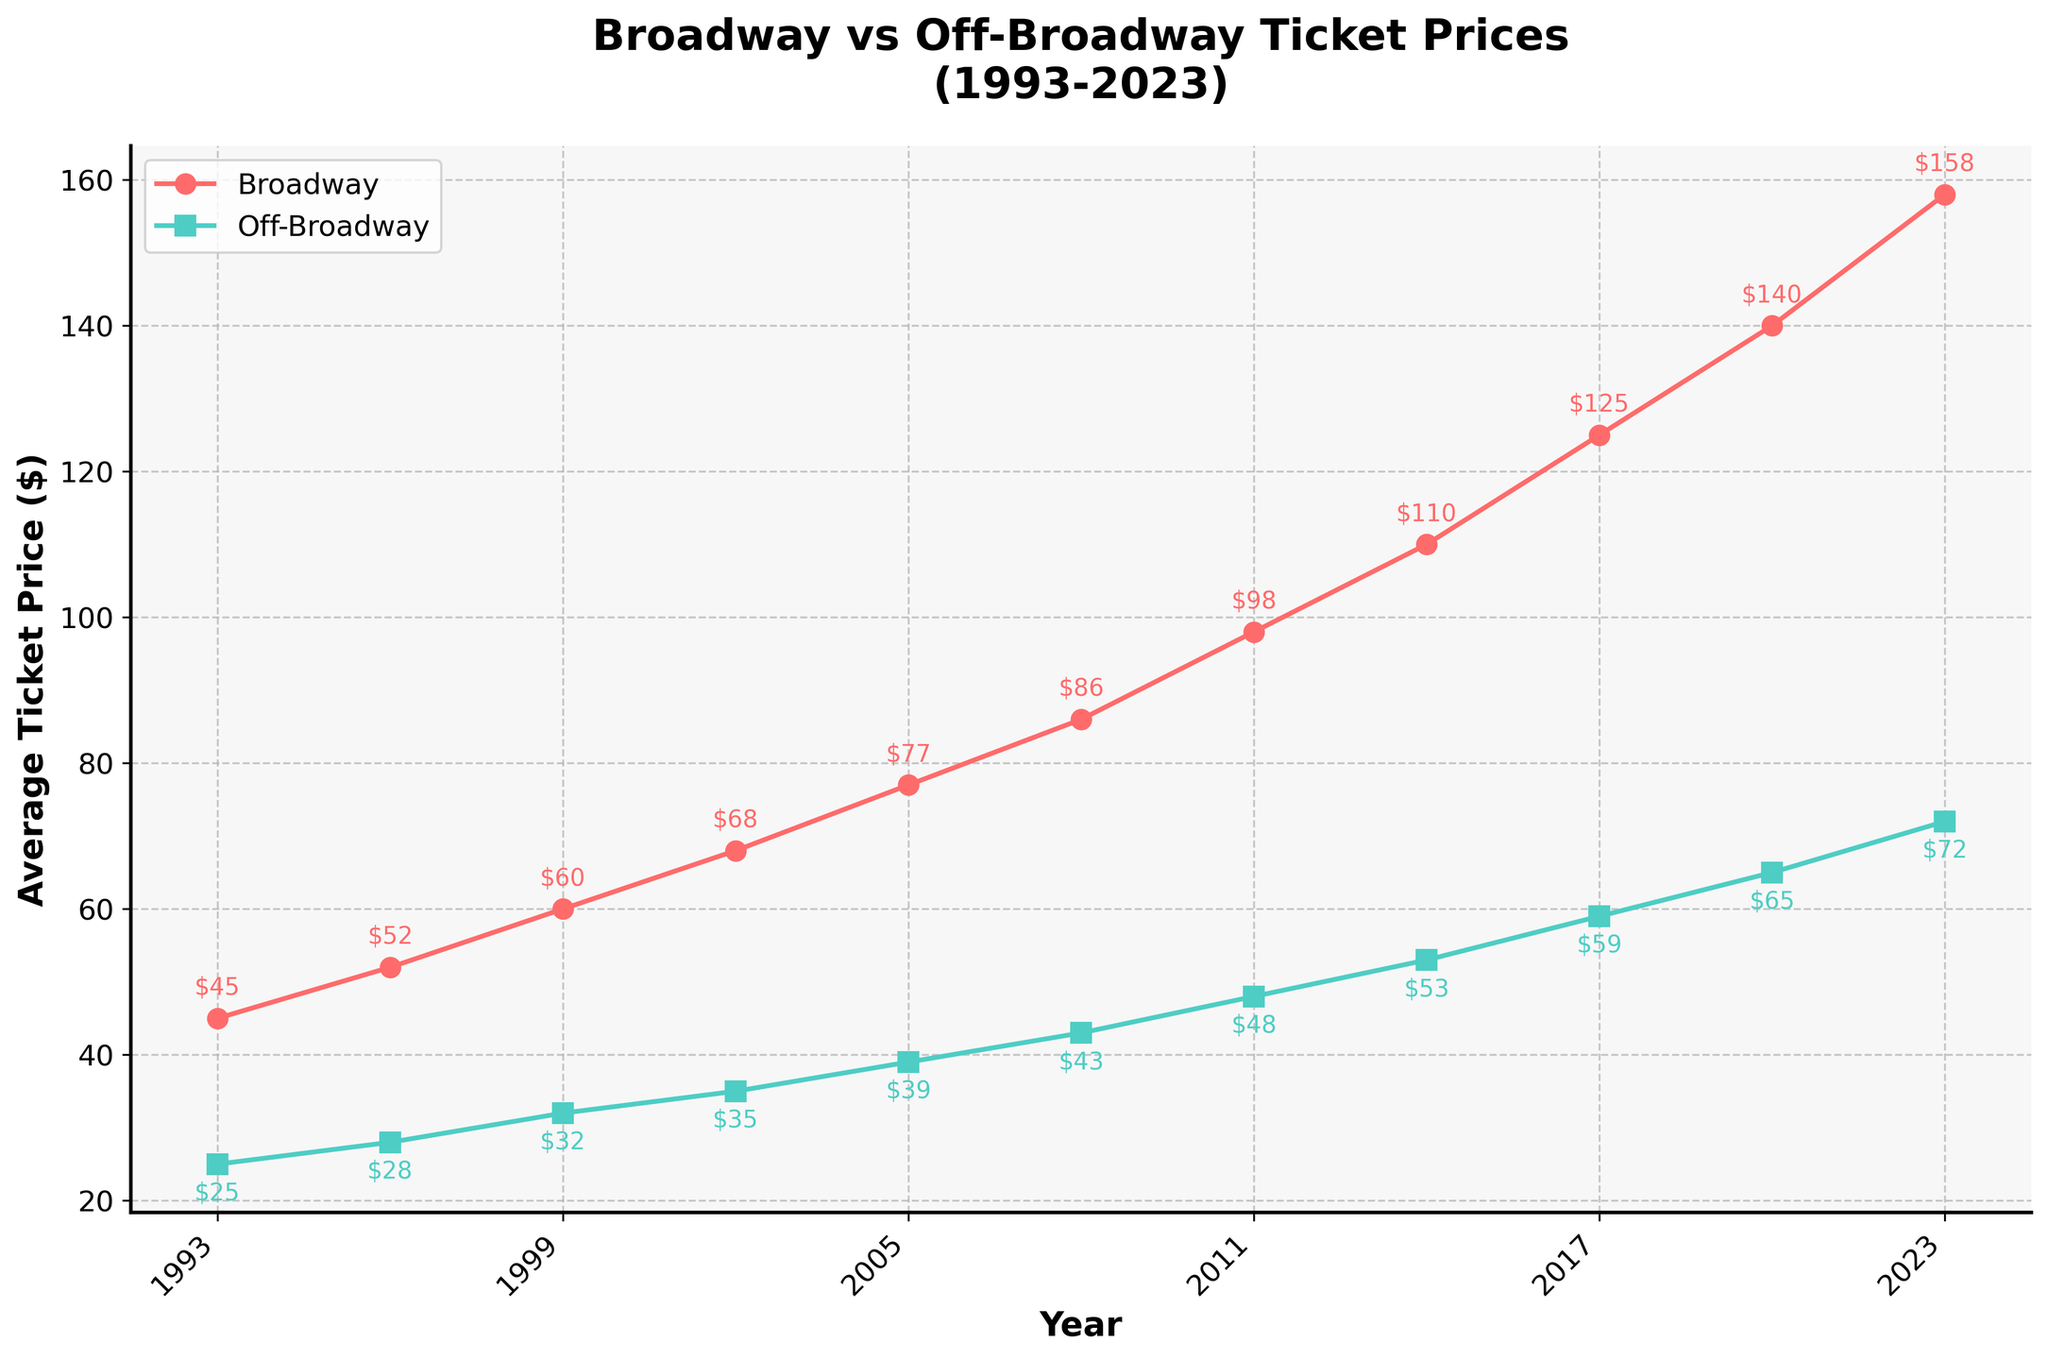What is the average Broadway ticket price in 2023? Look at the point marked on the Broadway line for the year 2023 and read its value.
Answer: $158 In which year did Off-Broadway ticket prices cross the $50 mark? Follow the Off-Broadway line and check where it first exceeds the $50 value mark.
Answer: 2014 What’s the price difference between Broadway and Off-Broadway tickets in 2005? Find the ticket prices for both lines in 2005 and calculate the difference: $77 (Broadway) - $39 (Off-Broadway).
Answer: $38 Which type of ticket experienced a higher price increase from 1993 to 2023, Broadway or Off-Broadway? Calculate the price increase for both: 
Broadway: $158 (2023) - $45 (1993) = $113;
Off-Broadway: $72 (2023) - $25 (1993) = $47;
Compare the two increases.
Answer: Broadway Between which two consecutive years did Off-Broadway ticket prices see the largest increase? Check the intervals between consecutive points on the Off-Broadway line and identify the largest vertical gap:
1993-1996: $3
1996-1999: $4
1999-2002: $3
2002-2005: $4
2005-2008: $4
2008-2011: $5
2011-2014: $5
2014-2017: $6
2017-2020: $6
2020-2023: $7
Calculate each increase and find the largest one.
Answer: 2020-2023 What is the trend in Broadway ticket prices from 1993 to 2023? Observe the slope of the Broadway line from 1993 to 2023: It rises steadily each year.
Answer: Increasing How much more expensive are Broadway tickets compared to Off-Broadway tickets, on average, over the three decades? Calculate the average difference over all years: (45-25 + 52-28 + 60-32 + 68-35 + 77-39 + 86-43 + 98-48 + 110-53 + 125-59 + 140-65 + 158-72)/11 = (20 + 24 + 28 + 33 + 38 + 43 + 50 + 57 + 66 + 75 + 86) / 11 = 52.7
Answer: $52.7 How do the trends of Broadway vs Off-Broadway ticket prices compare visually? Both lines increase, but the Broadway ticket prices rise steeper than the Off-Broadway ticket prices.
Answer: Broadway increases more steeply What's the greatest price difference between Broadway and Off-Broadway tickets? Find the greatest vertical distance between the two lines across years: The largest difference is in 2023.
Answer: $158 - $72 = $86 